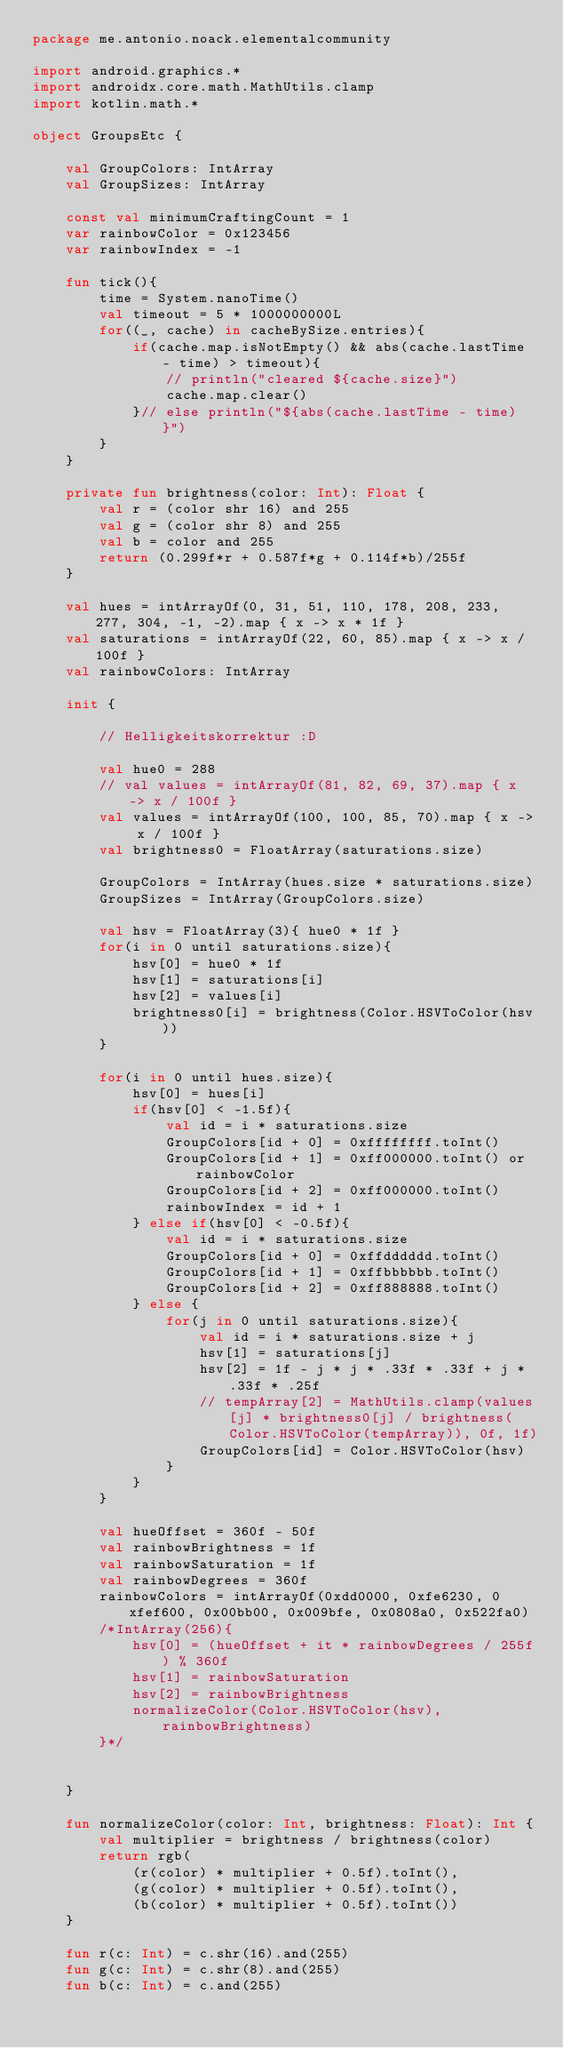<code> <loc_0><loc_0><loc_500><loc_500><_Kotlin_>package me.antonio.noack.elementalcommunity

import android.graphics.*
import androidx.core.math.MathUtils.clamp
import kotlin.math.*

object GroupsEtc {

    val GroupColors: IntArray
    val GroupSizes: IntArray

    const val minimumCraftingCount = 1
    var rainbowColor = 0x123456
    var rainbowIndex = -1

    fun tick(){
        time = System.nanoTime()
        val timeout = 5 * 1000000000L
        for((_, cache) in cacheBySize.entries){
            if(cache.map.isNotEmpty() && abs(cache.lastTime - time) > timeout){
                // println("cleared ${cache.size}")
                cache.map.clear()
            }// else println("${abs(cache.lastTime - time)}")
        }
    }

    private fun brightness(color: Int): Float {
        val r = (color shr 16) and 255
        val g = (color shr 8) and 255
        val b = color and 255
        return (0.299f*r + 0.587f*g + 0.114f*b)/255f
    }

    val hues = intArrayOf(0, 31, 51, 110, 178, 208, 233, 277, 304, -1, -2).map { x -> x * 1f }
    val saturations = intArrayOf(22, 60, 85).map { x -> x / 100f }
    val rainbowColors: IntArray

    init {

        // Helligkeitskorrektur :D

        val hue0 = 288
        // val values = intArrayOf(81, 82, 69, 37).map { x -> x / 100f }
        val values = intArrayOf(100, 100, 85, 70).map { x -> x / 100f }
        val brightness0 = FloatArray(saturations.size)

        GroupColors = IntArray(hues.size * saturations.size)
        GroupSizes = IntArray(GroupColors.size)

        val hsv = FloatArray(3){ hue0 * 1f }
        for(i in 0 until saturations.size){
            hsv[0] = hue0 * 1f
            hsv[1] = saturations[i]
            hsv[2] = values[i]
            brightness0[i] = brightness(Color.HSVToColor(hsv))
        }

        for(i in 0 until hues.size){
            hsv[0] = hues[i]
            if(hsv[0] < -1.5f){
                val id = i * saturations.size
                GroupColors[id + 0] = 0xffffffff.toInt()
                GroupColors[id + 1] = 0xff000000.toInt() or rainbowColor
                GroupColors[id + 2] = 0xff000000.toInt()
                rainbowIndex = id + 1
            } else if(hsv[0] < -0.5f){
                val id = i * saturations.size
                GroupColors[id + 0] = 0xffdddddd.toInt()
                GroupColors[id + 1] = 0xffbbbbbb.toInt()
                GroupColors[id + 2] = 0xff888888.toInt()
            } else {
                for(j in 0 until saturations.size){
                    val id = i * saturations.size + j
                    hsv[1] = saturations[j]
                    hsv[2] = 1f - j * j * .33f * .33f + j * .33f * .25f
                    // tempArray[2] = MathUtils.clamp(values[j] * brightness0[j] / brightness(Color.HSVToColor(tempArray)), 0f, 1f)
                    GroupColors[id] = Color.HSVToColor(hsv)
                }
            }
        }

        val hueOffset = 360f - 50f
        val rainbowBrightness = 1f
        val rainbowSaturation = 1f
        val rainbowDegrees = 360f
        rainbowColors = intArrayOf(0xdd0000, 0xfe6230, 0xfef600, 0x00bb00, 0x009bfe, 0x0808a0, 0x522fa0)
        /*IntArray(256){
            hsv[0] = (hueOffset + it * rainbowDegrees / 255f) % 360f
            hsv[1] = rainbowSaturation
            hsv[2] = rainbowBrightness
            normalizeColor(Color.HSVToColor(hsv), rainbowBrightness)
        }*/


    }

    fun normalizeColor(color: Int, brightness: Float): Int {
        val multiplier = brightness / brightness(color)
        return rgb(
            (r(color) * multiplier + 0.5f).toInt(),
            (g(color) * multiplier + 0.5f).toInt(),
            (b(color) * multiplier + 0.5f).toInt())
    }

    fun r(c: Int) = c.shr(16).and(255)
    fun g(c: Int) = c.shr(8).and(255)
    fun b(c: Int) = c.and(255)</code> 